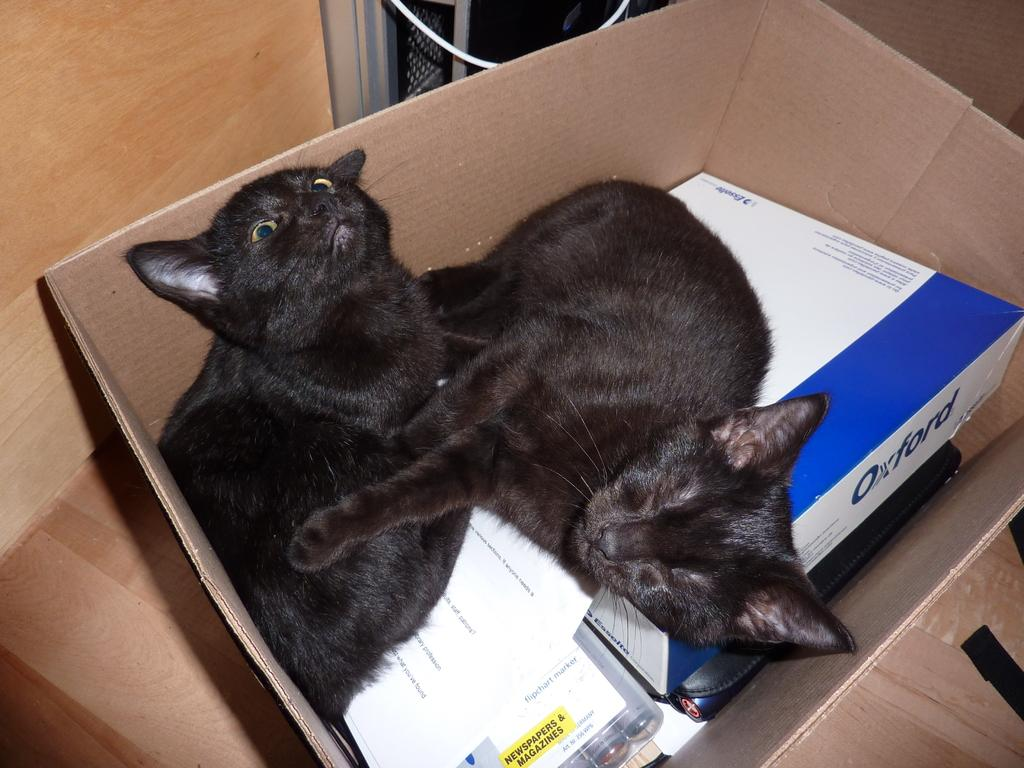What is located in the center of the image? There is a box in the center of the image. What is inside the box? There are cats, papers, and other objects in the box. What can be seen in the background of the image? There is a wall and other objects in the background of the image. What type of spot can be seen on the cats in the image? There is no mention of spots on the cats in the image; they are not described in any way. 